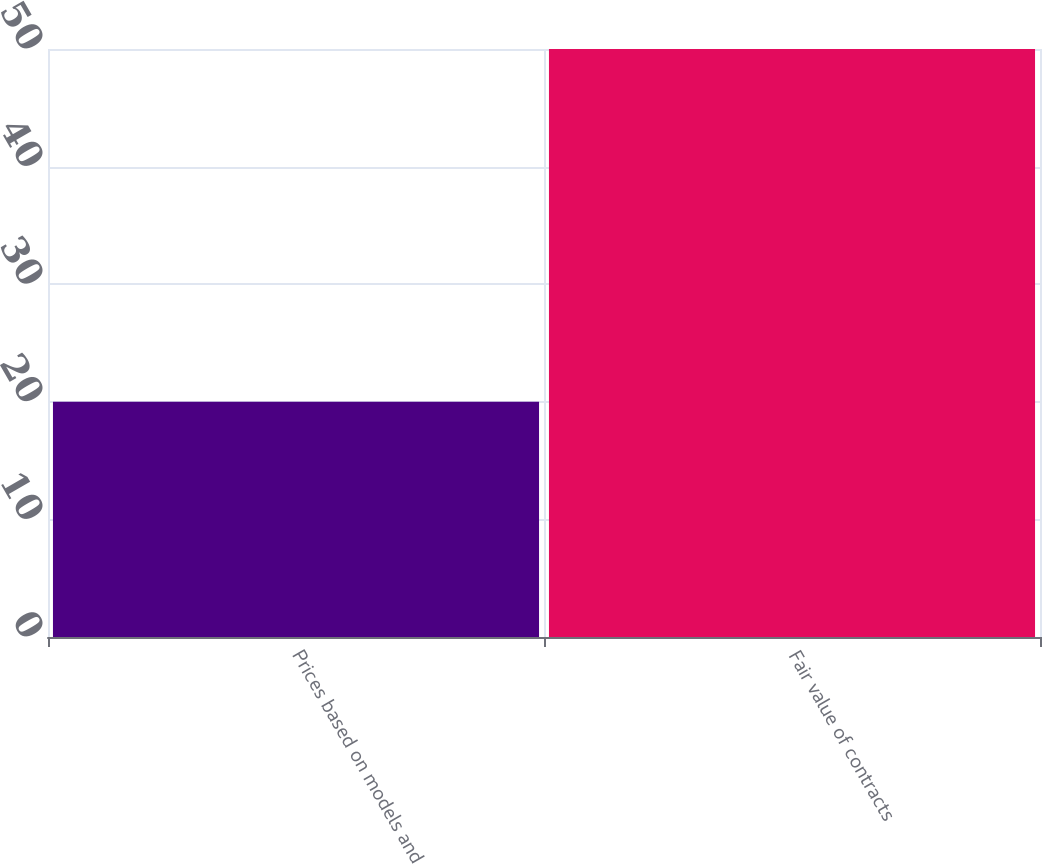Convert chart to OTSL. <chart><loc_0><loc_0><loc_500><loc_500><bar_chart><fcel>Prices based on models and<fcel>Fair value of contracts<nl><fcel>20<fcel>50<nl></chart> 